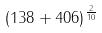Convert formula to latex. <formula><loc_0><loc_0><loc_500><loc_500>( 1 3 8 + 4 0 6 ) ^ { \frac { 2 } { 1 0 } }</formula> 